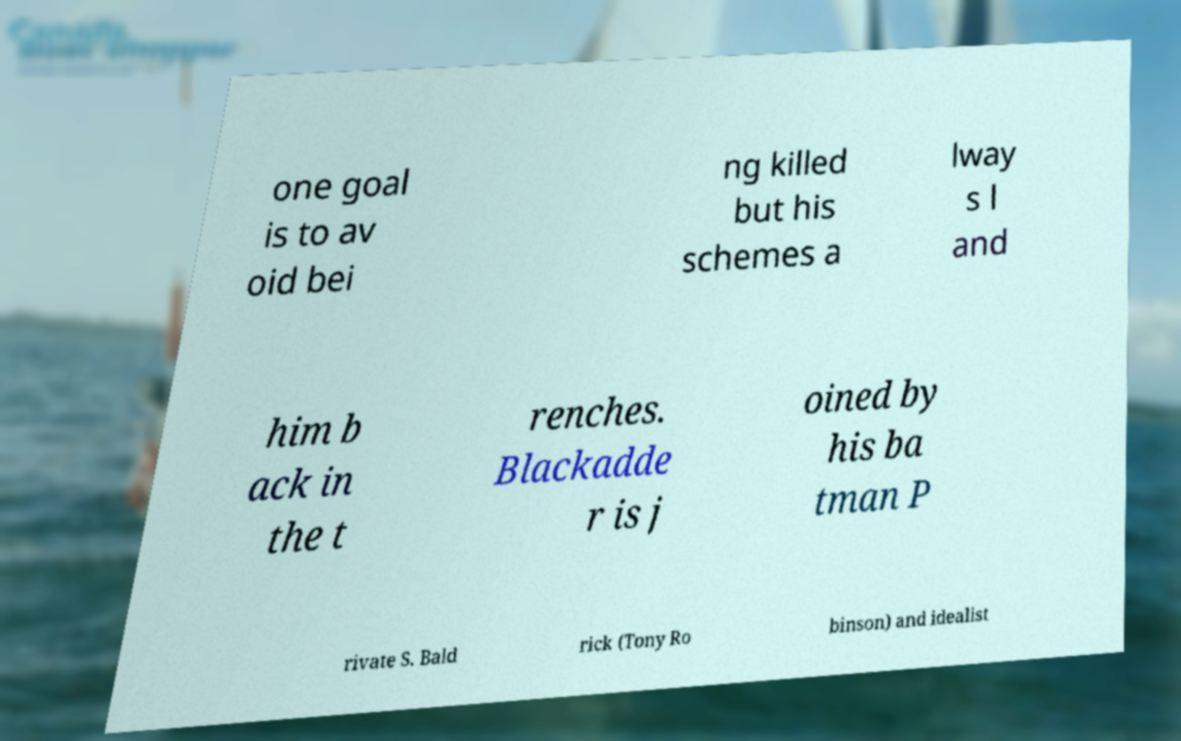Please identify and transcribe the text found in this image. one goal is to av oid bei ng killed but his schemes a lway s l and him b ack in the t renches. Blackadde r is j oined by his ba tman P rivate S. Bald rick (Tony Ro binson) and idealist 